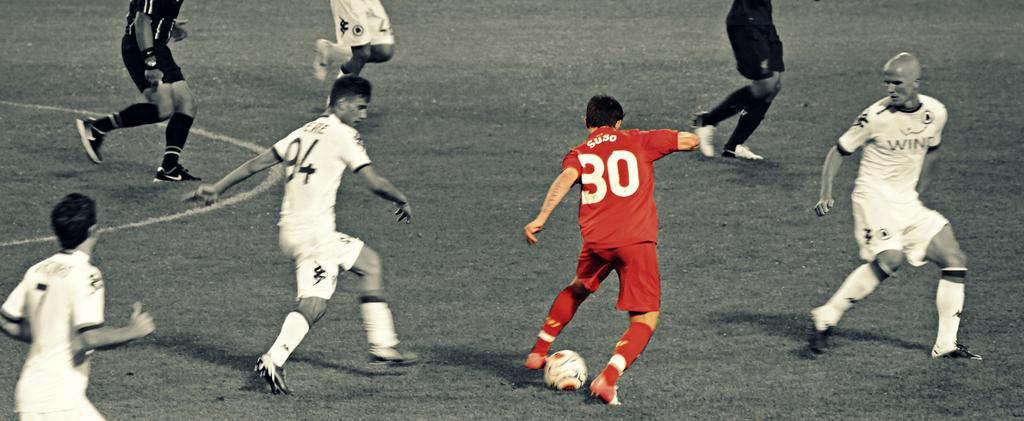Provide a one-sentence caption for the provided image. Soccer player number 94 trying to steal the ball from Suso number 30. 